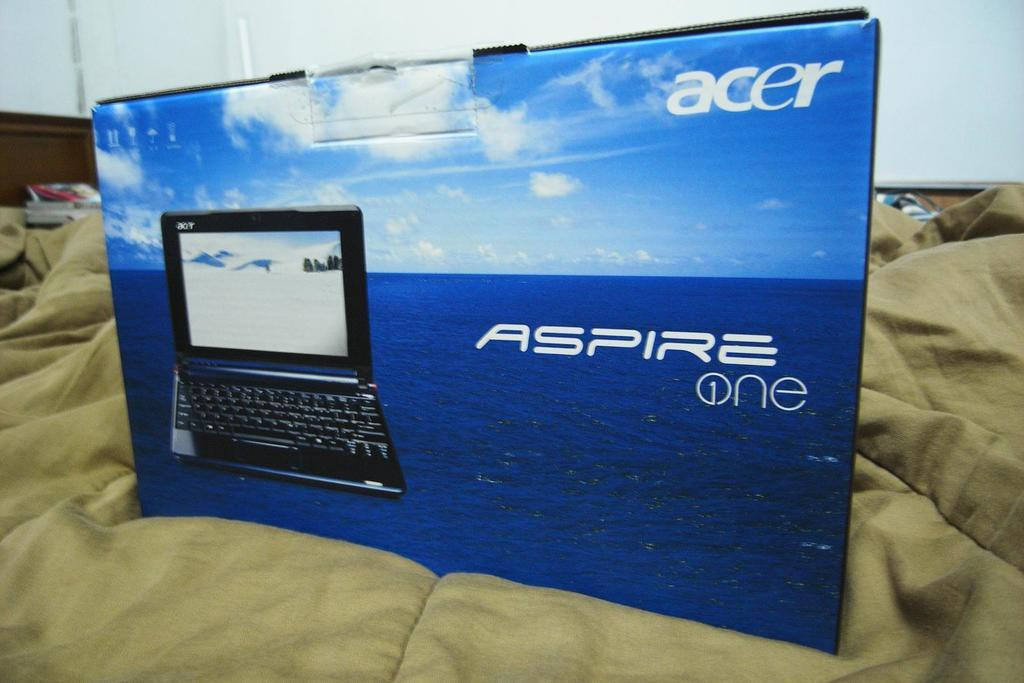<image>
Provide a brief description of the given image. an acer aspire one laptop box is sitting on a bed with green sheets 